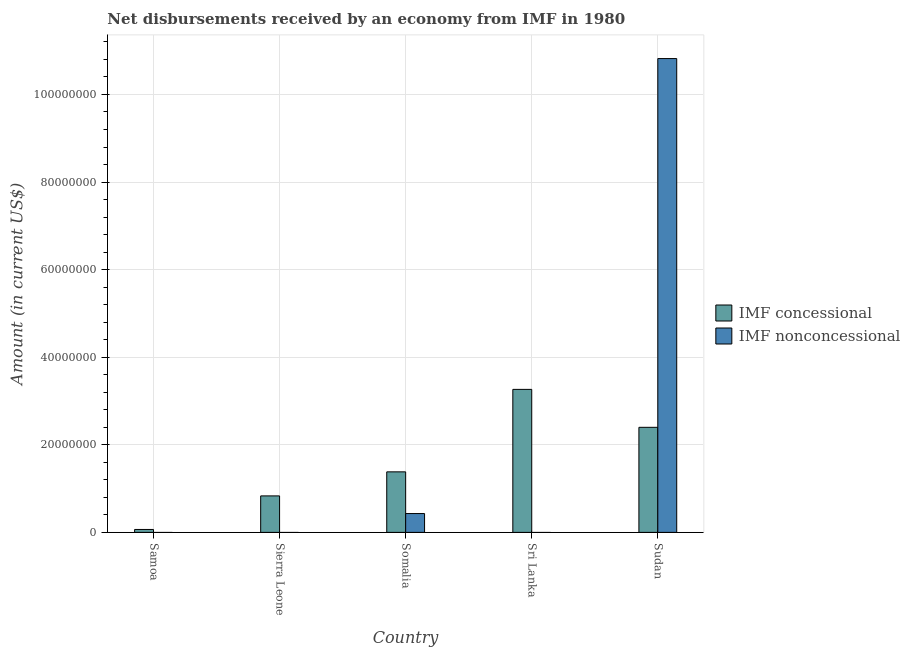Are the number of bars on each tick of the X-axis equal?
Offer a very short reply. No. How many bars are there on the 4th tick from the left?
Provide a short and direct response. 1. How many bars are there on the 1st tick from the right?
Keep it short and to the point. 2. What is the label of the 5th group of bars from the left?
Keep it short and to the point. Sudan. In how many cases, is the number of bars for a given country not equal to the number of legend labels?
Give a very brief answer. 3. What is the net non concessional disbursements from imf in Sudan?
Offer a very short reply. 1.08e+08. Across all countries, what is the maximum net concessional disbursements from imf?
Your answer should be compact. 3.27e+07. In which country was the net concessional disbursements from imf maximum?
Offer a terse response. Sri Lanka. What is the total net non concessional disbursements from imf in the graph?
Make the answer very short. 1.12e+08. What is the difference between the net concessional disbursements from imf in Samoa and that in Sri Lanka?
Provide a succinct answer. -3.20e+07. What is the difference between the net non concessional disbursements from imf in Samoa and the net concessional disbursements from imf in Somalia?
Your answer should be compact. -1.38e+07. What is the average net non concessional disbursements from imf per country?
Provide a short and direct response. 2.25e+07. What is the difference between the net non concessional disbursements from imf and net concessional disbursements from imf in Somalia?
Give a very brief answer. -9.52e+06. What is the ratio of the net concessional disbursements from imf in Sri Lanka to that in Sudan?
Give a very brief answer. 1.36. What is the difference between the highest and the second highest net concessional disbursements from imf?
Ensure brevity in your answer.  8.66e+06. What is the difference between the highest and the lowest net concessional disbursements from imf?
Provide a succinct answer. 3.20e+07. How many countries are there in the graph?
Your answer should be compact. 5. What is the difference between two consecutive major ticks on the Y-axis?
Your response must be concise. 2.00e+07. Are the values on the major ticks of Y-axis written in scientific E-notation?
Provide a succinct answer. No. Does the graph contain any zero values?
Ensure brevity in your answer.  Yes. Does the graph contain grids?
Your answer should be very brief. Yes. How many legend labels are there?
Ensure brevity in your answer.  2. What is the title of the graph?
Provide a succinct answer. Net disbursements received by an economy from IMF in 1980. Does "GDP per capita" appear as one of the legend labels in the graph?
Provide a short and direct response. No. What is the label or title of the X-axis?
Offer a terse response. Country. What is the Amount (in current US$) in IMF concessional in Samoa?
Offer a terse response. 6.66e+05. What is the Amount (in current US$) of IMF concessional in Sierra Leone?
Give a very brief answer. 8.33e+06. What is the Amount (in current US$) of IMF nonconcessional in Sierra Leone?
Provide a succinct answer. 0. What is the Amount (in current US$) of IMF concessional in Somalia?
Keep it short and to the point. 1.38e+07. What is the Amount (in current US$) in IMF nonconcessional in Somalia?
Provide a succinct answer. 4.30e+06. What is the Amount (in current US$) in IMF concessional in Sri Lanka?
Your response must be concise. 3.27e+07. What is the Amount (in current US$) in IMF concessional in Sudan?
Provide a short and direct response. 2.40e+07. What is the Amount (in current US$) of IMF nonconcessional in Sudan?
Your answer should be compact. 1.08e+08. Across all countries, what is the maximum Amount (in current US$) in IMF concessional?
Keep it short and to the point. 3.27e+07. Across all countries, what is the maximum Amount (in current US$) of IMF nonconcessional?
Your response must be concise. 1.08e+08. Across all countries, what is the minimum Amount (in current US$) in IMF concessional?
Give a very brief answer. 6.66e+05. What is the total Amount (in current US$) of IMF concessional in the graph?
Provide a succinct answer. 7.95e+07. What is the total Amount (in current US$) of IMF nonconcessional in the graph?
Your response must be concise. 1.12e+08. What is the difference between the Amount (in current US$) in IMF concessional in Samoa and that in Sierra Leone?
Your answer should be very brief. -7.66e+06. What is the difference between the Amount (in current US$) of IMF concessional in Samoa and that in Somalia?
Your response must be concise. -1.32e+07. What is the difference between the Amount (in current US$) in IMF concessional in Samoa and that in Sri Lanka?
Make the answer very short. -3.20e+07. What is the difference between the Amount (in current US$) of IMF concessional in Samoa and that in Sudan?
Provide a short and direct response. -2.33e+07. What is the difference between the Amount (in current US$) in IMF concessional in Sierra Leone and that in Somalia?
Provide a succinct answer. -5.49e+06. What is the difference between the Amount (in current US$) of IMF concessional in Sierra Leone and that in Sri Lanka?
Your answer should be compact. -2.43e+07. What is the difference between the Amount (in current US$) of IMF concessional in Sierra Leone and that in Sudan?
Ensure brevity in your answer.  -1.57e+07. What is the difference between the Amount (in current US$) in IMF concessional in Somalia and that in Sri Lanka?
Ensure brevity in your answer.  -1.88e+07. What is the difference between the Amount (in current US$) of IMF concessional in Somalia and that in Sudan?
Give a very brief answer. -1.02e+07. What is the difference between the Amount (in current US$) of IMF nonconcessional in Somalia and that in Sudan?
Your answer should be very brief. -1.04e+08. What is the difference between the Amount (in current US$) in IMF concessional in Sri Lanka and that in Sudan?
Your answer should be very brief. 8.66e+06. What is the difference between the Amount (in current US$) in IMF concessional in Samoa and the Amount (in current US$) in IMF nonconcessional in Somalia?
Offer a terse response. -3.63e+06. What is the difference between the Amount (in current US$) in IMF concessional in Samoa and the Amount (in current US$) in IMF nonconcessional in Sudan?
Your answer should be very brief. -1.08e+08. What is the difference between the Amount (in current US$) in IMF concessional in Sierra Leone and the Amount (in current US$) in IMF nonconcessional in Somalia?
Offer a very short reply. 4.03e+06. What is the difference between the Amount (in current US$) in IMF concessional in Sierra Leone and the Amount (in current US$) in IMF nonconcessional in Sudan?
Your response must be concise. -9.99e+07. What is the difference between the Amount (in current US$) in IMF concessional in Somalia and the Amount (in current US$) in IMF nonconcessional in Sudan?
Provide a succinct answer. -9.44e+07. What is the difference between the Amount (in current US$) of IMF concessional in Sri Lanka and the Amount (in current US$) of IMF nonconcessional in Sudan?
Make the answer very short. -7.55e+07. What is the average Amount (in current US$) in IMF concessional per country?
Your answer should be compact. 1.59e+07. What is the average Amount (in current US$) in IMF nonconcessional per country?
Offer a very short reply. 2.25e+07. What is the difference between the Amount (in current US$) of IMF concessional and Amount (in current US$) of IMF nonconcessional in Somalia?
Provide a short and direct response. 9.52e+06. What is the difference between the Amount (in current US$) of IMF concessional and Amount (in current US$) of IMF nonconcessional in Sudan?
Give a very brief answer. -8.42e+07. What is the ratio of the Amount (in current US$) of IMF concessional in Samoa to that in Somalia?
Provide a short and direct response. 0.05. What is the ratio of the Amount (in current US$) in IMF concessional in Samoa to that in Sri Lanka?
Keep it short and to the point. 0.02. What is the ratio of the Amount (in current US$) in IMF concessional in Samoa to that in Sudan?
Provide a short and direct response. 0.03. What is the ratio of the Amount (in current US$) in IMF concessional in Sierra Leone to that in Somalia?
Ensure brevity in your answer.  0.6. What is the ratio of the Amount (in current US$) in IMF concessional in Sierra Leone to that in Sri Lanka?
Offer a very short reply. 0.26. What is the ratio of the Amount (in current US$) in IMF concessional in Sierra Leone to that in Sudan?
Provide a succinct answer. 0.35. What is the ratio of the Amount (in current US$) in IMF concessional in Somalia to that in Sri Lanka?
Your answer should be compact. 0.42. What is the ratio of the Amount (in current US$) of IMF concessional in Somalia to that in Sudan?
Provide a succinct answer. 0.58. What is the ratio of the Amount (in current US$) of IMF nonconcessional in Somalia to that in Sudan?
Offer a terse response. 0.04. What is the ratio of the Amount (in current US$) of IMF concessional in Sri Lanka to that in Sudan?
Ensure brevity in your answer.  1.36. What is the difference between the highest and the second highest Amount (in current US$) in IMF concessional?
Offer a very short reply. 8.66e+06. What is the difference between the highest and the lowest Amount (in current US$) in IMF concessional?
Offer a very short reply. 3.20e+07. What is the difference between the highest and the lowest Amount (in current US$) of IMF nonconcessional?
Your response must be concise. 1.08e+08. 